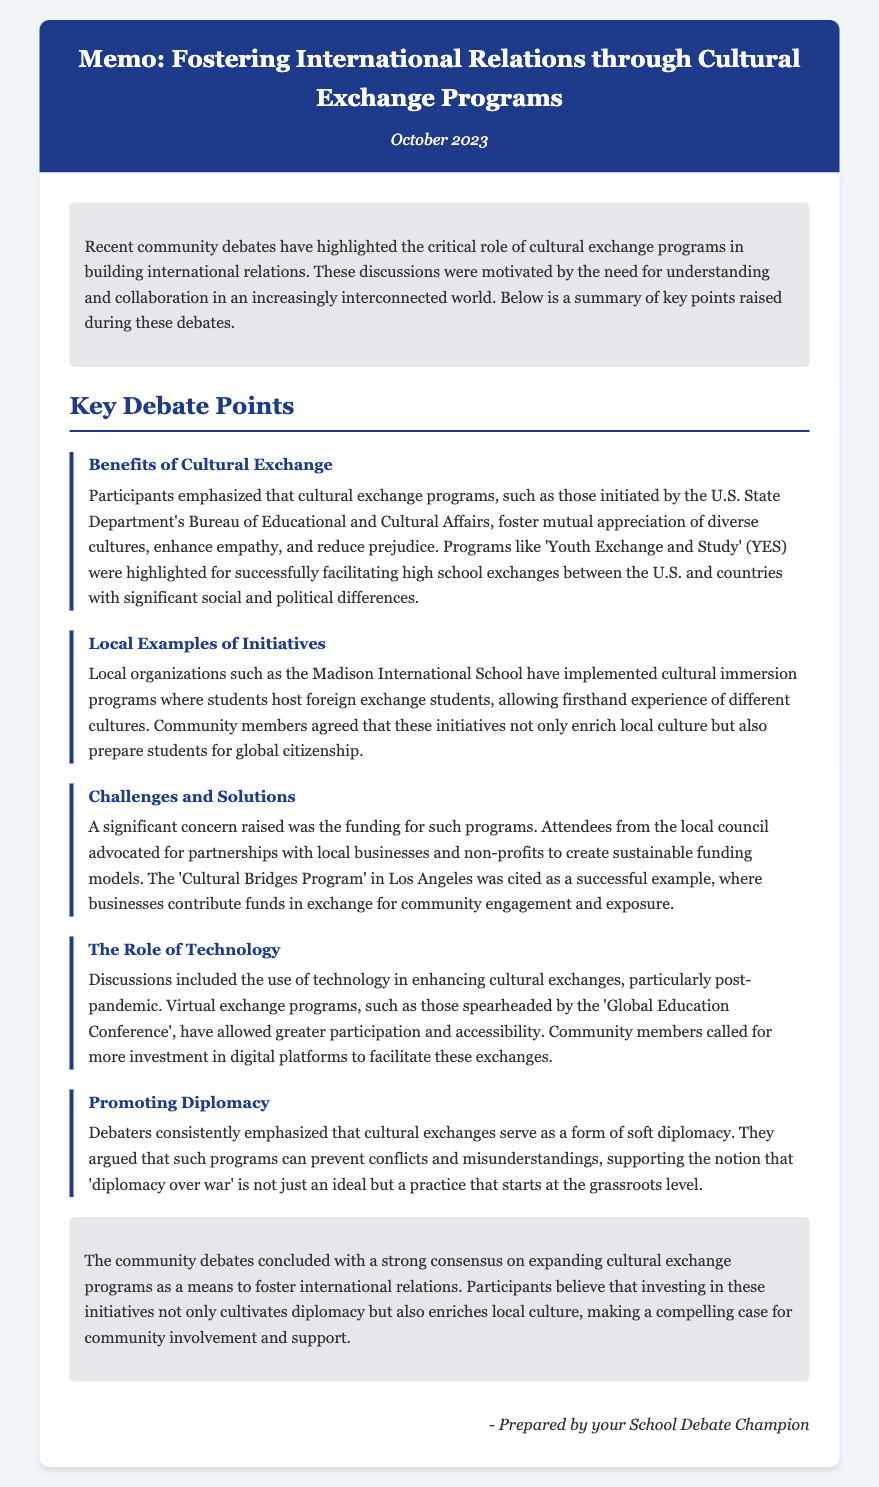What month is the memo dated? The date of the memo is clearly stated in the header section.
Answer: October 2023 What is the main focus of the community debates? The introduction of the memo highlights the critical role of cultural exchange programs.
Answer: Cultural exchange programs Which organization initiated programs mentioned in the debate? The details in the benefits section specify the U.S. State Department's Bureau of Educational and Cultural Affairs.
Answer: U.S. State Department's Bureau of Educational and Cultural Affairs What local school is mentioned for cultural immersion programs? The specific school noted for its initiatives is detailed in the local examples section.
Answer: Madison International School What was a significant concern regarding cultural exchange programs? The challenges section of the memo identifies funding as a major concern during the debates.
Answer: Funding Which program in Los Angeles is cited as a successful example? The challenges section mentions a specific program as a model for funding partnerships.
Answer: Cultural Bridges Program What role do cultural exchanges play according to the debaters? The debaters discussed the importance of cultural exchanges in promoting international understanding.
Answer: Soft diplomacy What technological adaptation was highlighted post-pandemic? The role of technology section mentions virtual exchange programs enhancing accessibility.
Answer: Virtual exchange programs Who prepared the memo? The conclusion includes the signature that identifies the author of the memo.
Answer: Your School Debate Champion 